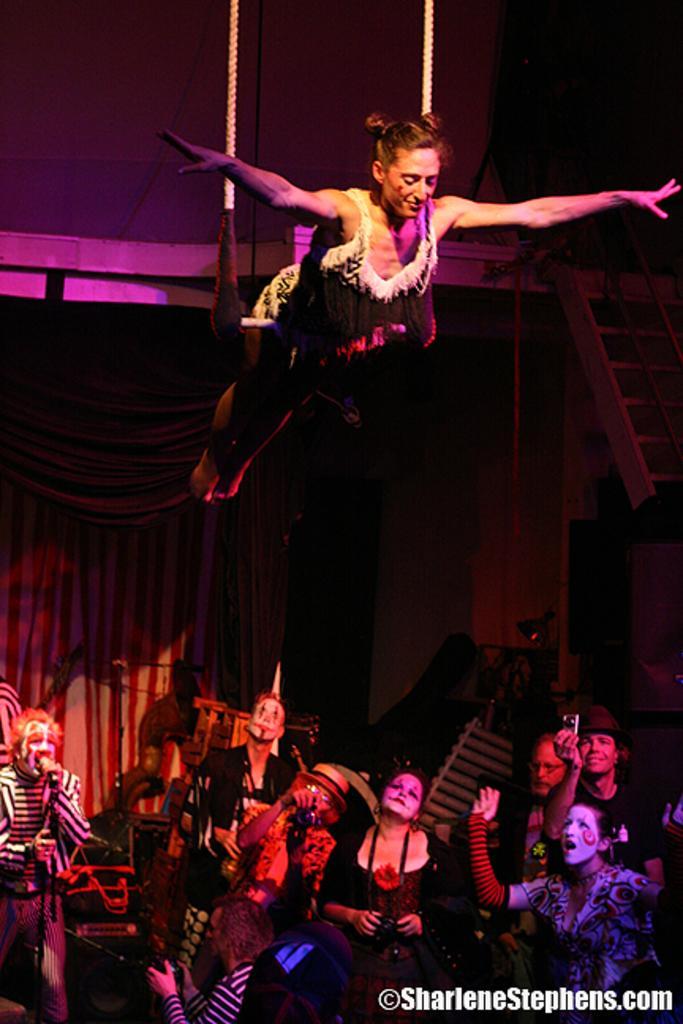Could you give a brief overview of what you see in this image? In this picture we can see women in the air, down we can see few people. 